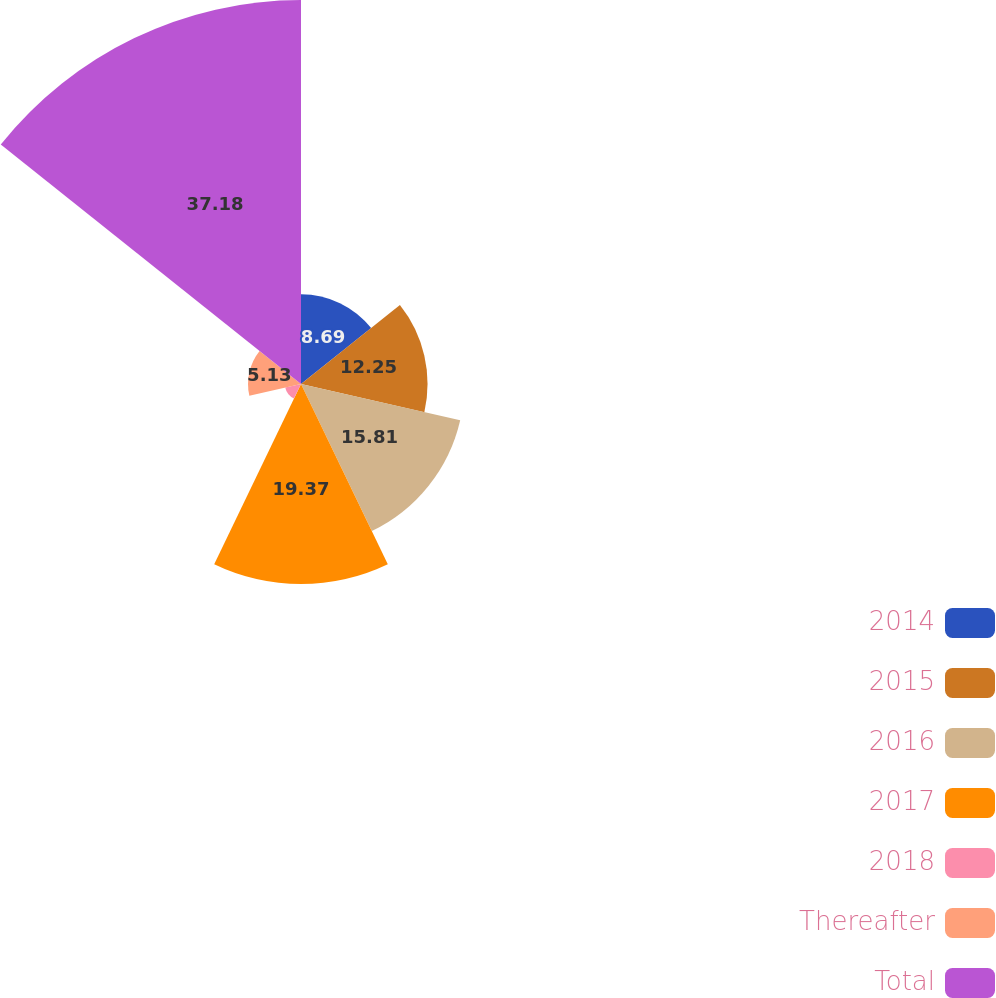<chart> <loc_0><loc_0><loc_500><loc_500><pie_chart><fcel>2014<fcel>2015<fcel>2016<fcel>2017<fcel>2018<fcel>Thereafter<fcel>Total<nl><fcel>8.69%<fcel>12.25%<fcel>15.81%<fcel>19.37%<fcel>1.57%<fcel>5.13%<fcel>37.18%<nl></chart> 